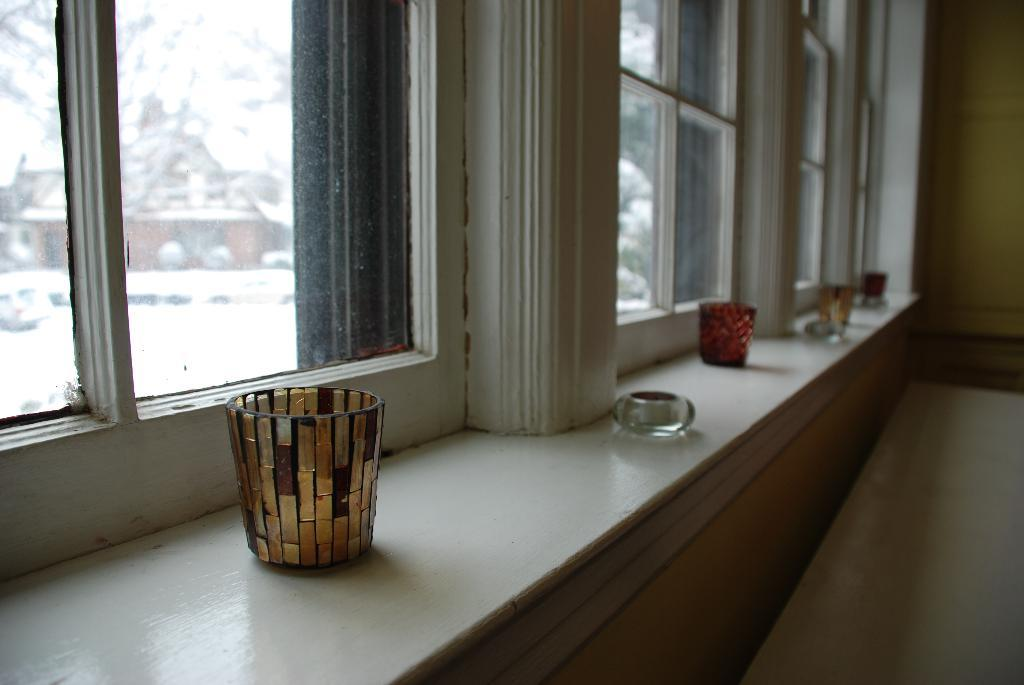What can be seen through the windows in the image? The objects in front of the windows prevent us from seeing what is outside. What is the purpose of the glasses on the wall? The glasses on the wall are likely for drinking purposes. Where is the door located in the image? The door is on the right side of the image. How many spiders are crawling on the quilt in the image? There are no spiders or quilts present in the image. What type of stocking is hanging near the door in the image? There is no stocking present in the image. 